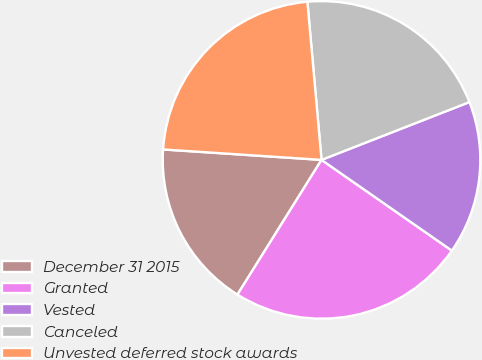Convert chart. <chart><loc_0><loc_0><loc_500><loc_500><pie_chart><fcel>December 31 2015<fcel>Granted<fcel>Vested<fcel>Canceled<fcel>Unvested deferred stock awards<nl><fcel>17.17%<fcel>24.2%<fcel>15.61%<fcel>20.49%<fcel>22.53%<nl></chart> 